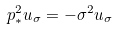Convert formula to latex. <formula><loc_0><loc_0><loc_500><loc_500>p _ { * } ^ { 2 } u _ { \sigma } = - \sigma ^ { 2 } u _ { \sigma }</formula> 